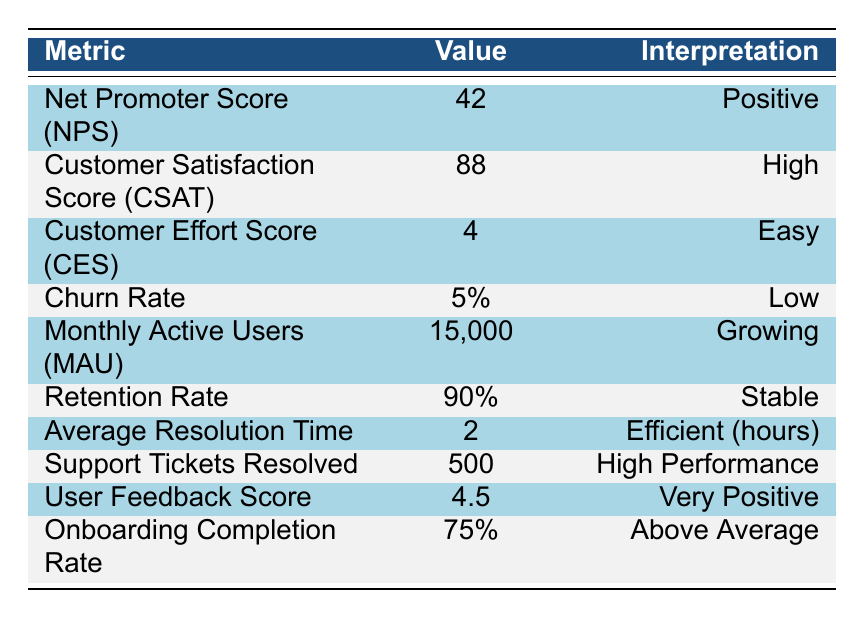What is the Net Promoter Score (NPS) for the SaaS product? The table states that the Net Promoter Score (NPS) value is 42.
Answer: 42 What is the Customer Satisfaction Score (CSAT)? According to the table, the Customer Satisfaction Score (CSAT) is listed as 88.
Answer: 88 Is the Churn Rate high or low? The table indicates that the Churn Rate is 5%, which corresponds to a low level of churn.
Answer: Low What percentage of users completed the onboarding process? The Onboarding Completion Rate in the table shows a value of 75%.
Answer: 75% What is the average resolution time for support tickets? The Average Resolution Time provided in the table is 2 hours, indicating quick support.
Answer: 2 hours What is the difference between the Customer Satisfaction Score (CSAT) and the User Feedback Score? The CSAT is 88 and the User Feedback Score is 4.5. To compare them, convert the User Feedback Score to a percentage (4.5 out of 5 is 90%). The difference is 90 - 88 = 2.
Answer: 2 If the Retention Rate were to drop to 85%, what would be the new interpretation? The current Retention Rate is 90%, which is stable. If it drops to 85%, it would be interpreted as declining, since anything below 90% signifies potential issues in retaining customers.
Answer: Declining What is the total of Monthly Active Users (MAU) and Support Tickets Resolved? The Monthly Active Users (MAU) is 15,000 and Support Tickets Resolved is 500. When added together, 15,000 + 500 equals 15,500.
Answer: 15,500 Is the Average Resolution Time efficient based on the table? The table shows that the Average Resolution Time is 2 hours. Since this figure is labeled as "Efficient," it confirms that it meets the efficient standard set in the metrics.
Answer: Yes If a company were to improve the Customer Effort Score (CES) by 1 point, what would its new value be? The current CES is 4. If it improves by 1 point, it would become 5.
Answer: 5 